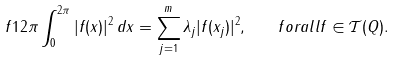<formula> <loc_0><loc_0><loc_500><loc_500>\ f 1 { 2 \pi } \int _ { 0 } ^ { 2 \pi } | f ( x ) | ^ { 2 } \, d x = \sum _ { j = 1 } ^ { m } \lambda _ { j } | f ( x _ { j } ) | ^ { 2 } , \ \ \ f o r a l l f \in \mathcal { T } ( Q ) .</formula> 